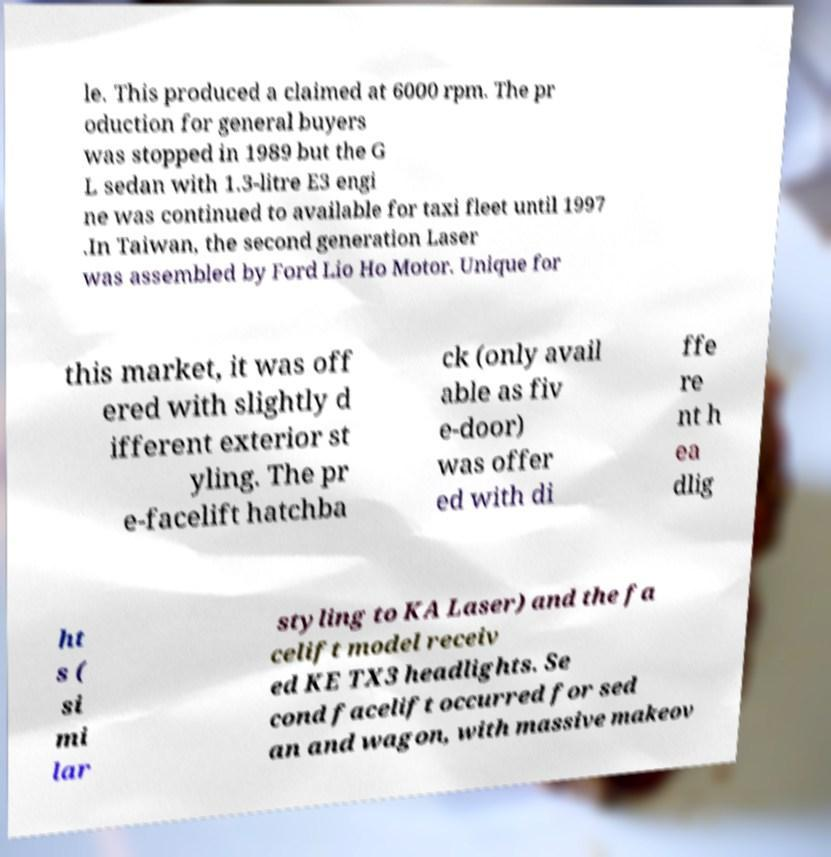Could you extract and type out the text from this image? le. This produced a claimed at 6000 rpm. The pr oduction for general buyers was stopped in 1989 but the G L sedan with 1.3-litre E3 engi ne was continued to available for taxi fleet until 1997 .In Taiwan, the second generation Laser was assembled by Ford Lio Ho Motor. Unique for this market, it was off ered with slightly d ifferent exterior st yling. The pr e-facelift hatchba ck (only avail able as fiv e-door) was offer ed with di ffe re nt h ea dlig ht s ( si mi lar styling to KA Laser) and the fa celift model receiv ed KE TX3 headlights. Se cond facelift occurred for sed an and wagon, with massive makeov 